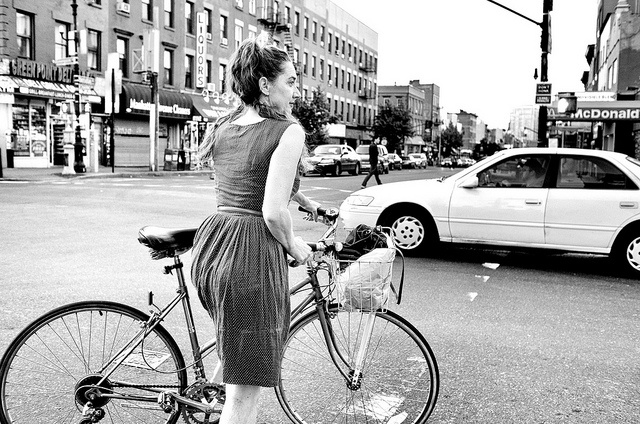Describe the objects in this image and their specific colors. I can see bicycle in darkgray, lightgray, black, and gray tones, people in darkgray, gray, lightgray, and black tones, car in darkgray, white, black, and gray tones, traffic light in darkgray, black, white, and gray tones, and car in darkgray, white, black, and gray tones in this image. 